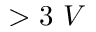<formula> <loc_0><loc_0><loc_500><loc_500>> 3 V</formula> 